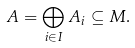<formula> <loc_0><loc_0><loc_500><loc_500>A = \bigoplus _ { i \in I } A _ { i } \subseteq M .</formula> 